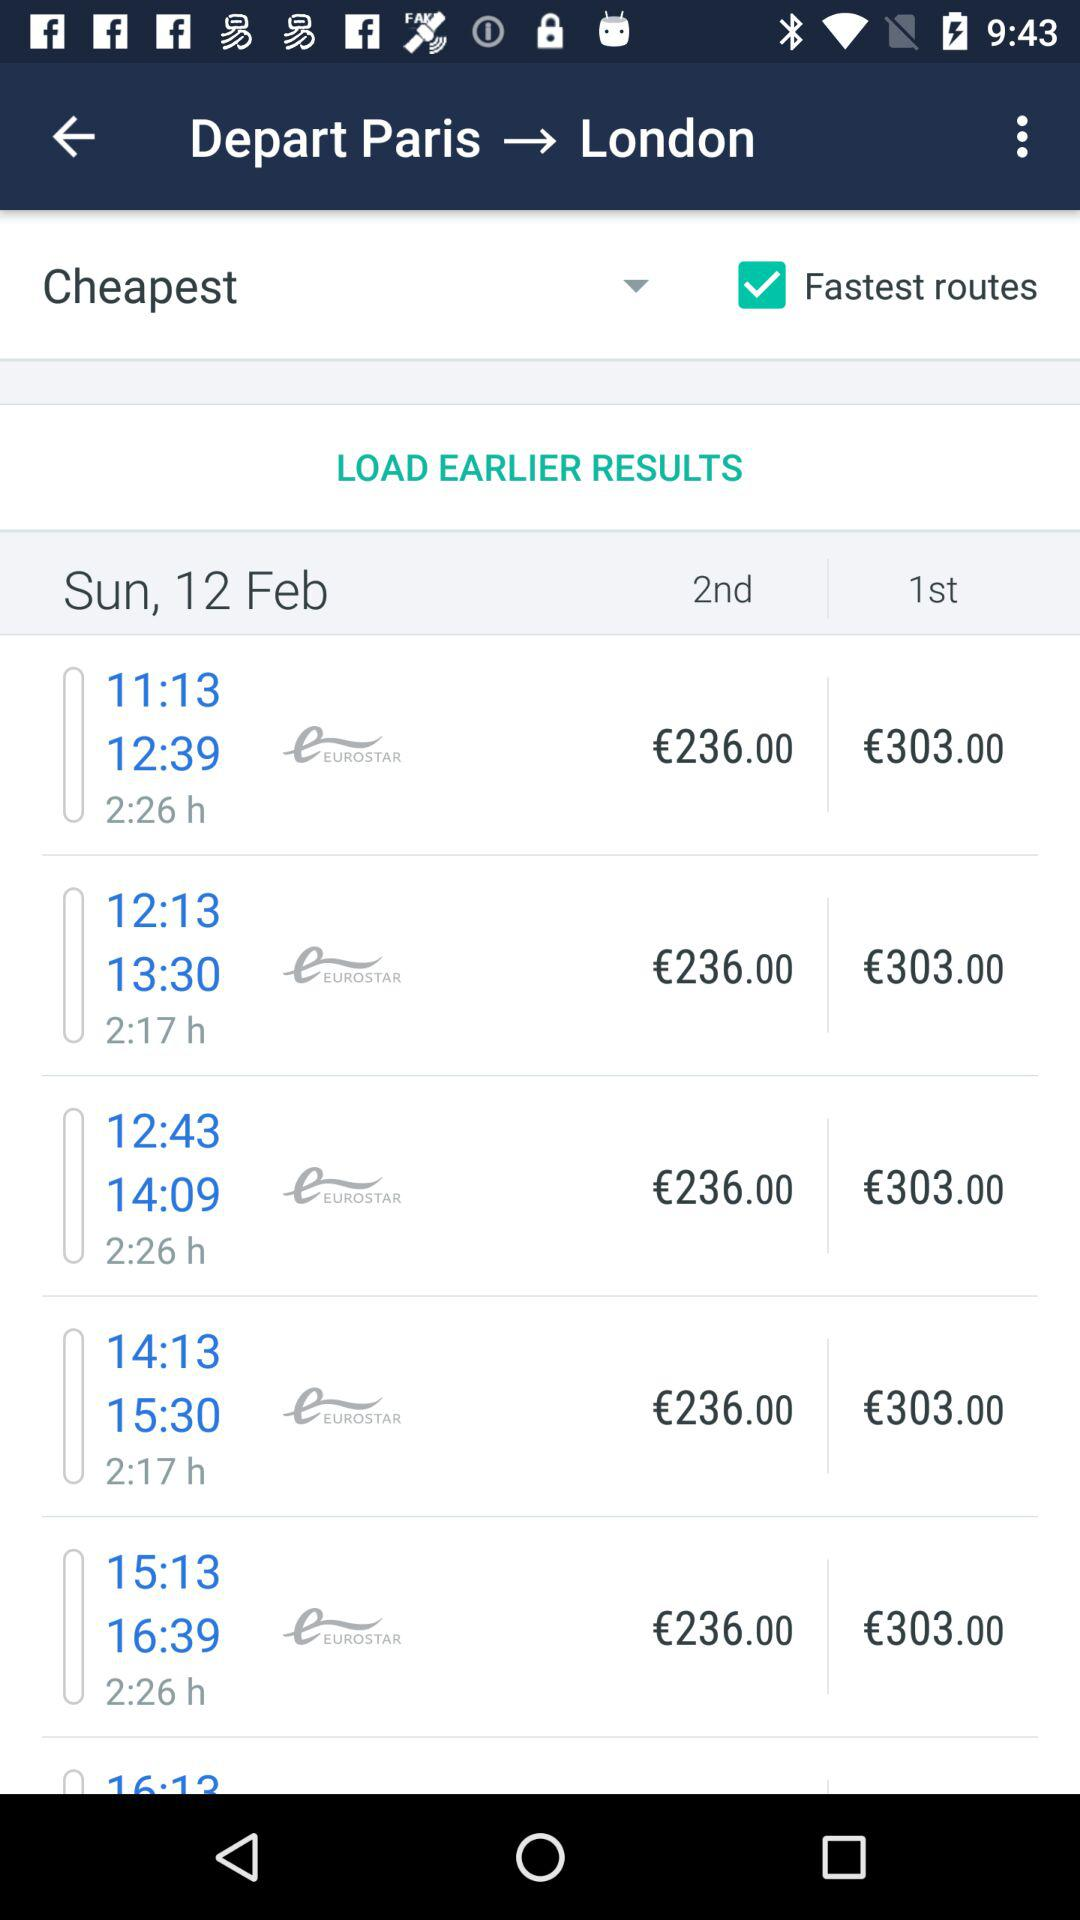How many euros is the cheapest ticket?
Answer the question using a single word or phrase. €236.00 